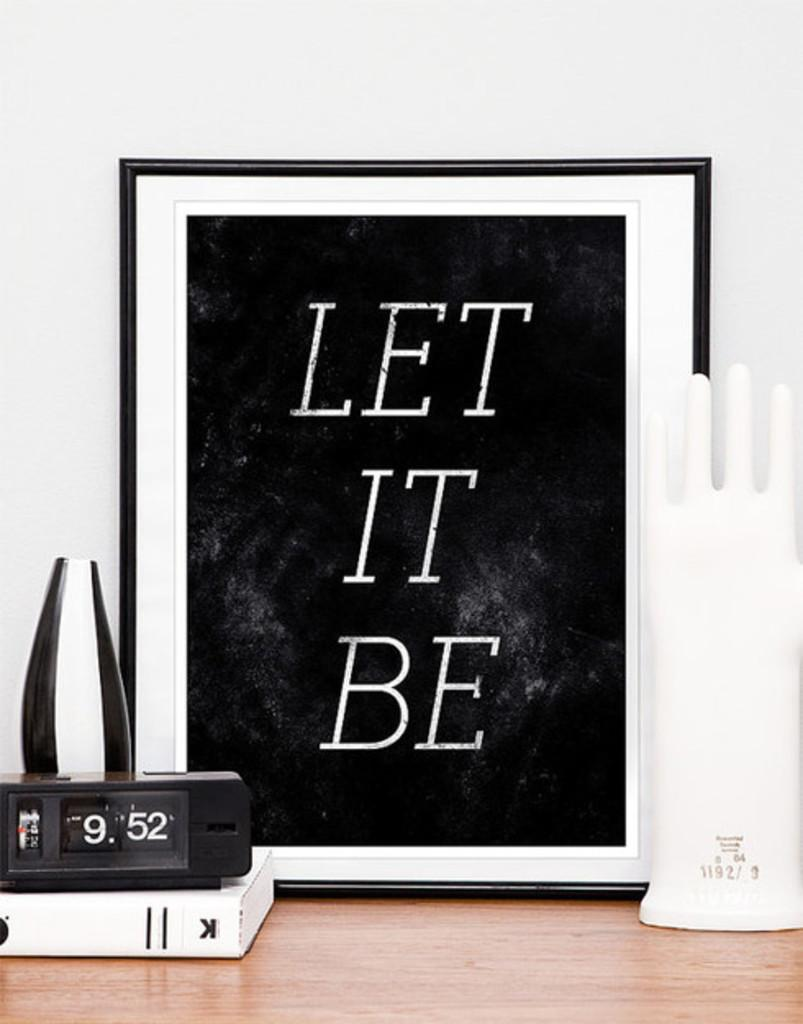<image>
Relay a brief, clear account of the picture shown. A picture with the words Let it Be are on a desk with a clock, vase, book and ring holder. 